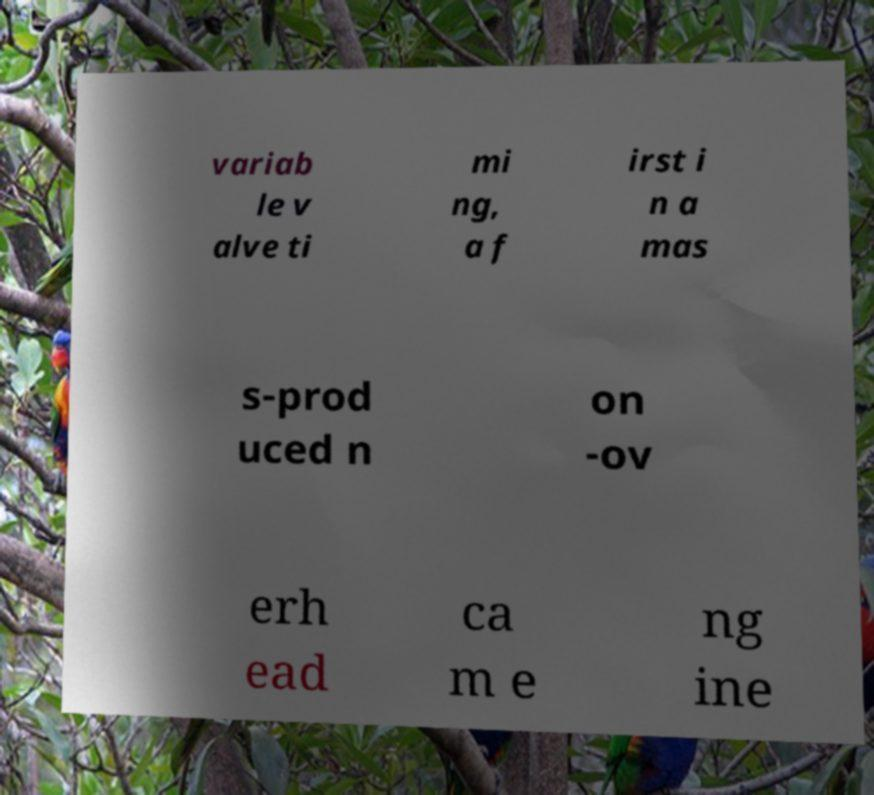There's text embedded in this image that I need extracted. Can you transcribe it verbatim? variab le v alve ti mi ng, a f irst i n a mas s-prod uced n on -ov erh ead ca m e ng ine 